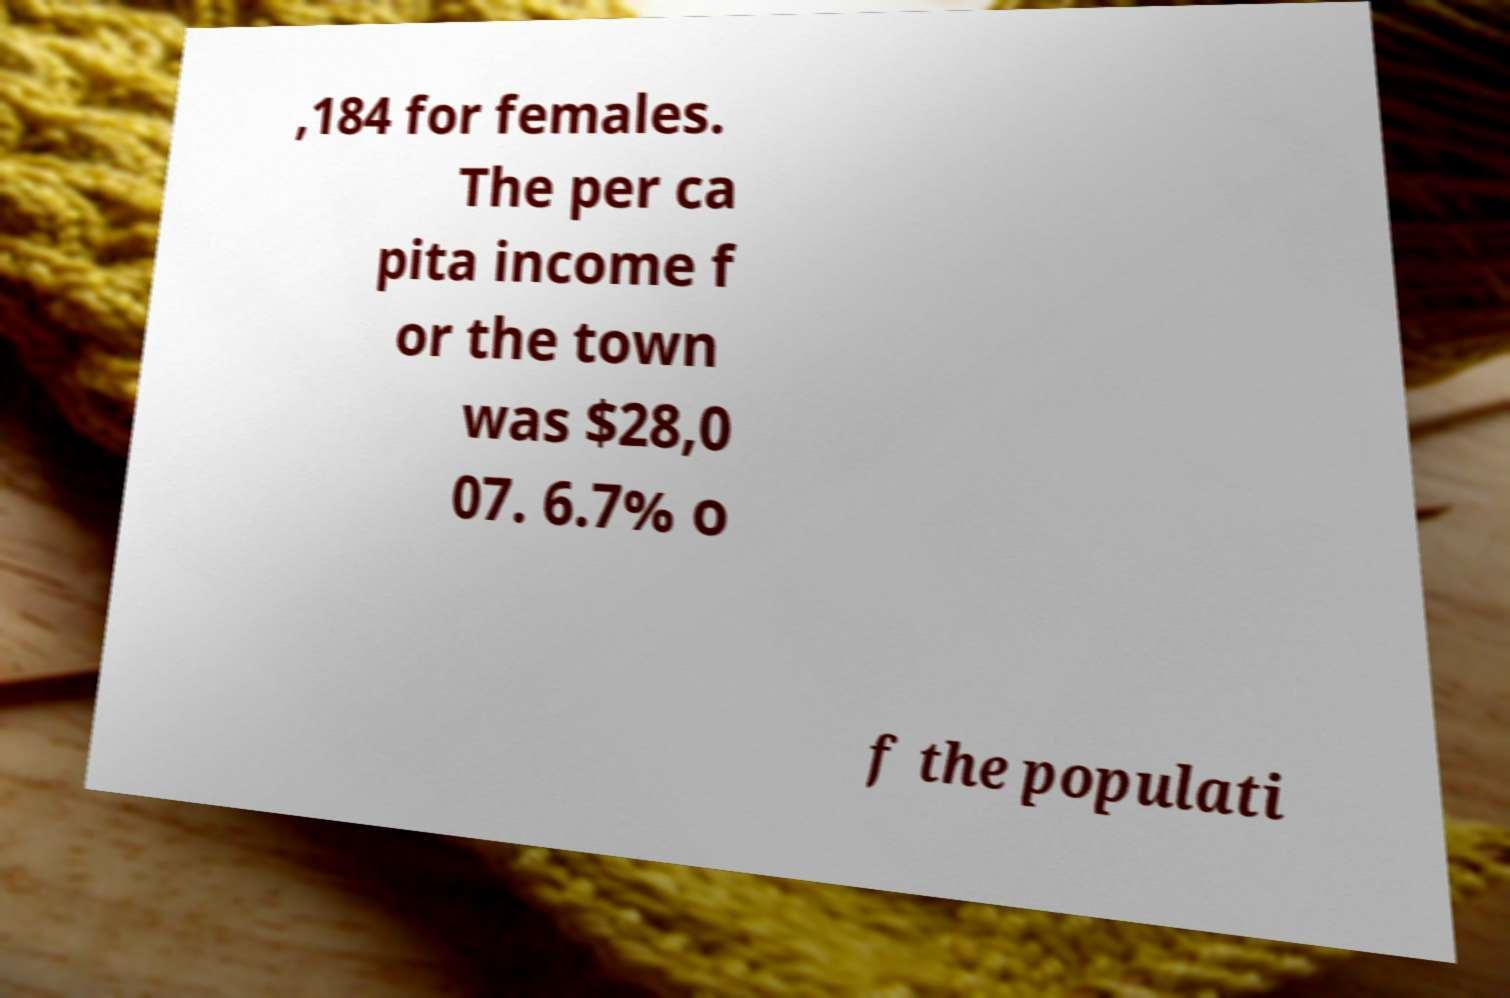For documentation purposes, I need the text within this image transcribed. Could you provide that? ,184 for females. The per ca pita income f or the town was $28,0 07. 6.7% o f the populati 